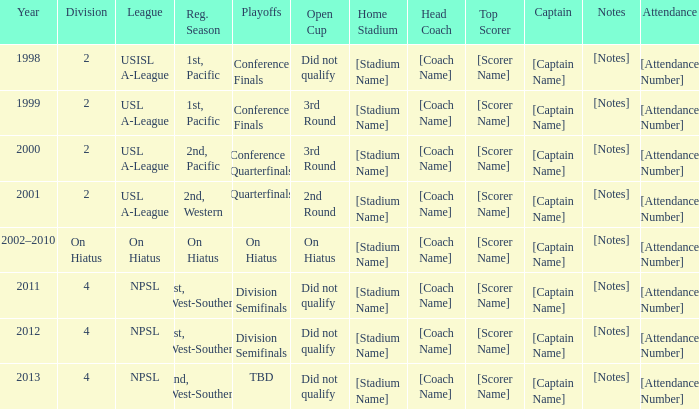Which open cup was in 2012? Did not qualify. 